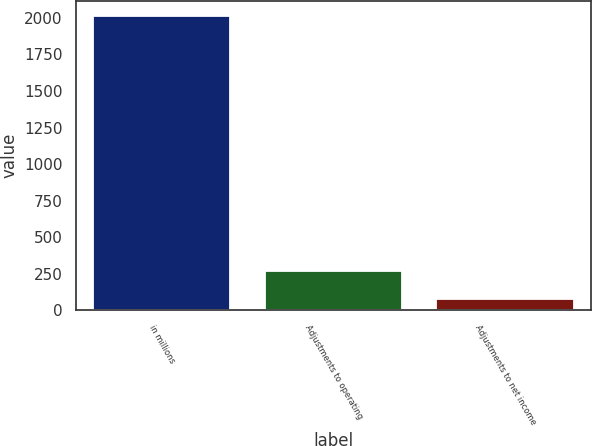<chart> <loc_0><loc_0><loc_500><loc_500><bar_chart><fcel>in millions<fcel>Adjustments to operating<fcel>Adjustments to net income<nl><fcel>2014<fcel>272.14<fcel>78.6<nl></chart> 